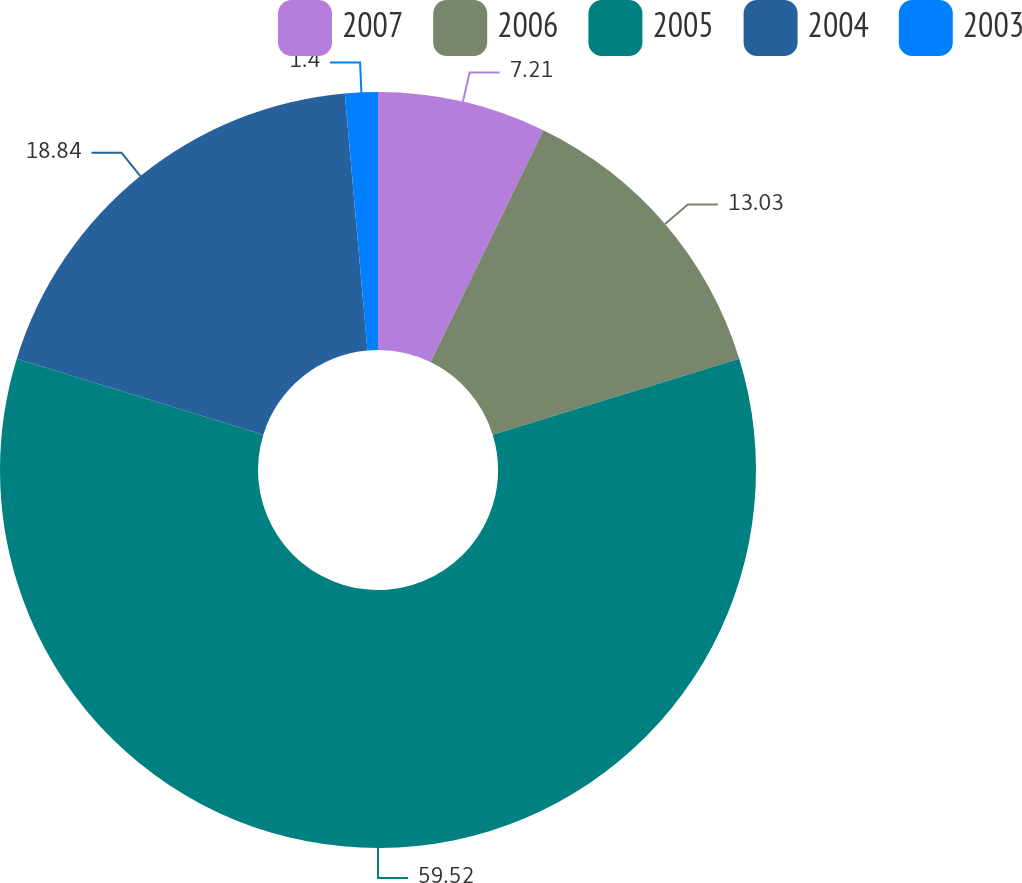<chart> <loc_0><loc_0><loc_500><loc_500><pie_chart><fcel>2007<fcel>2006<fcel>2005<fcel>2004<fcel>2003<nl><fcel>7.21%<fcel>13.03%<fcel>59.52%<fcel>18.84%<fcel>1.4%<nl></chart> 